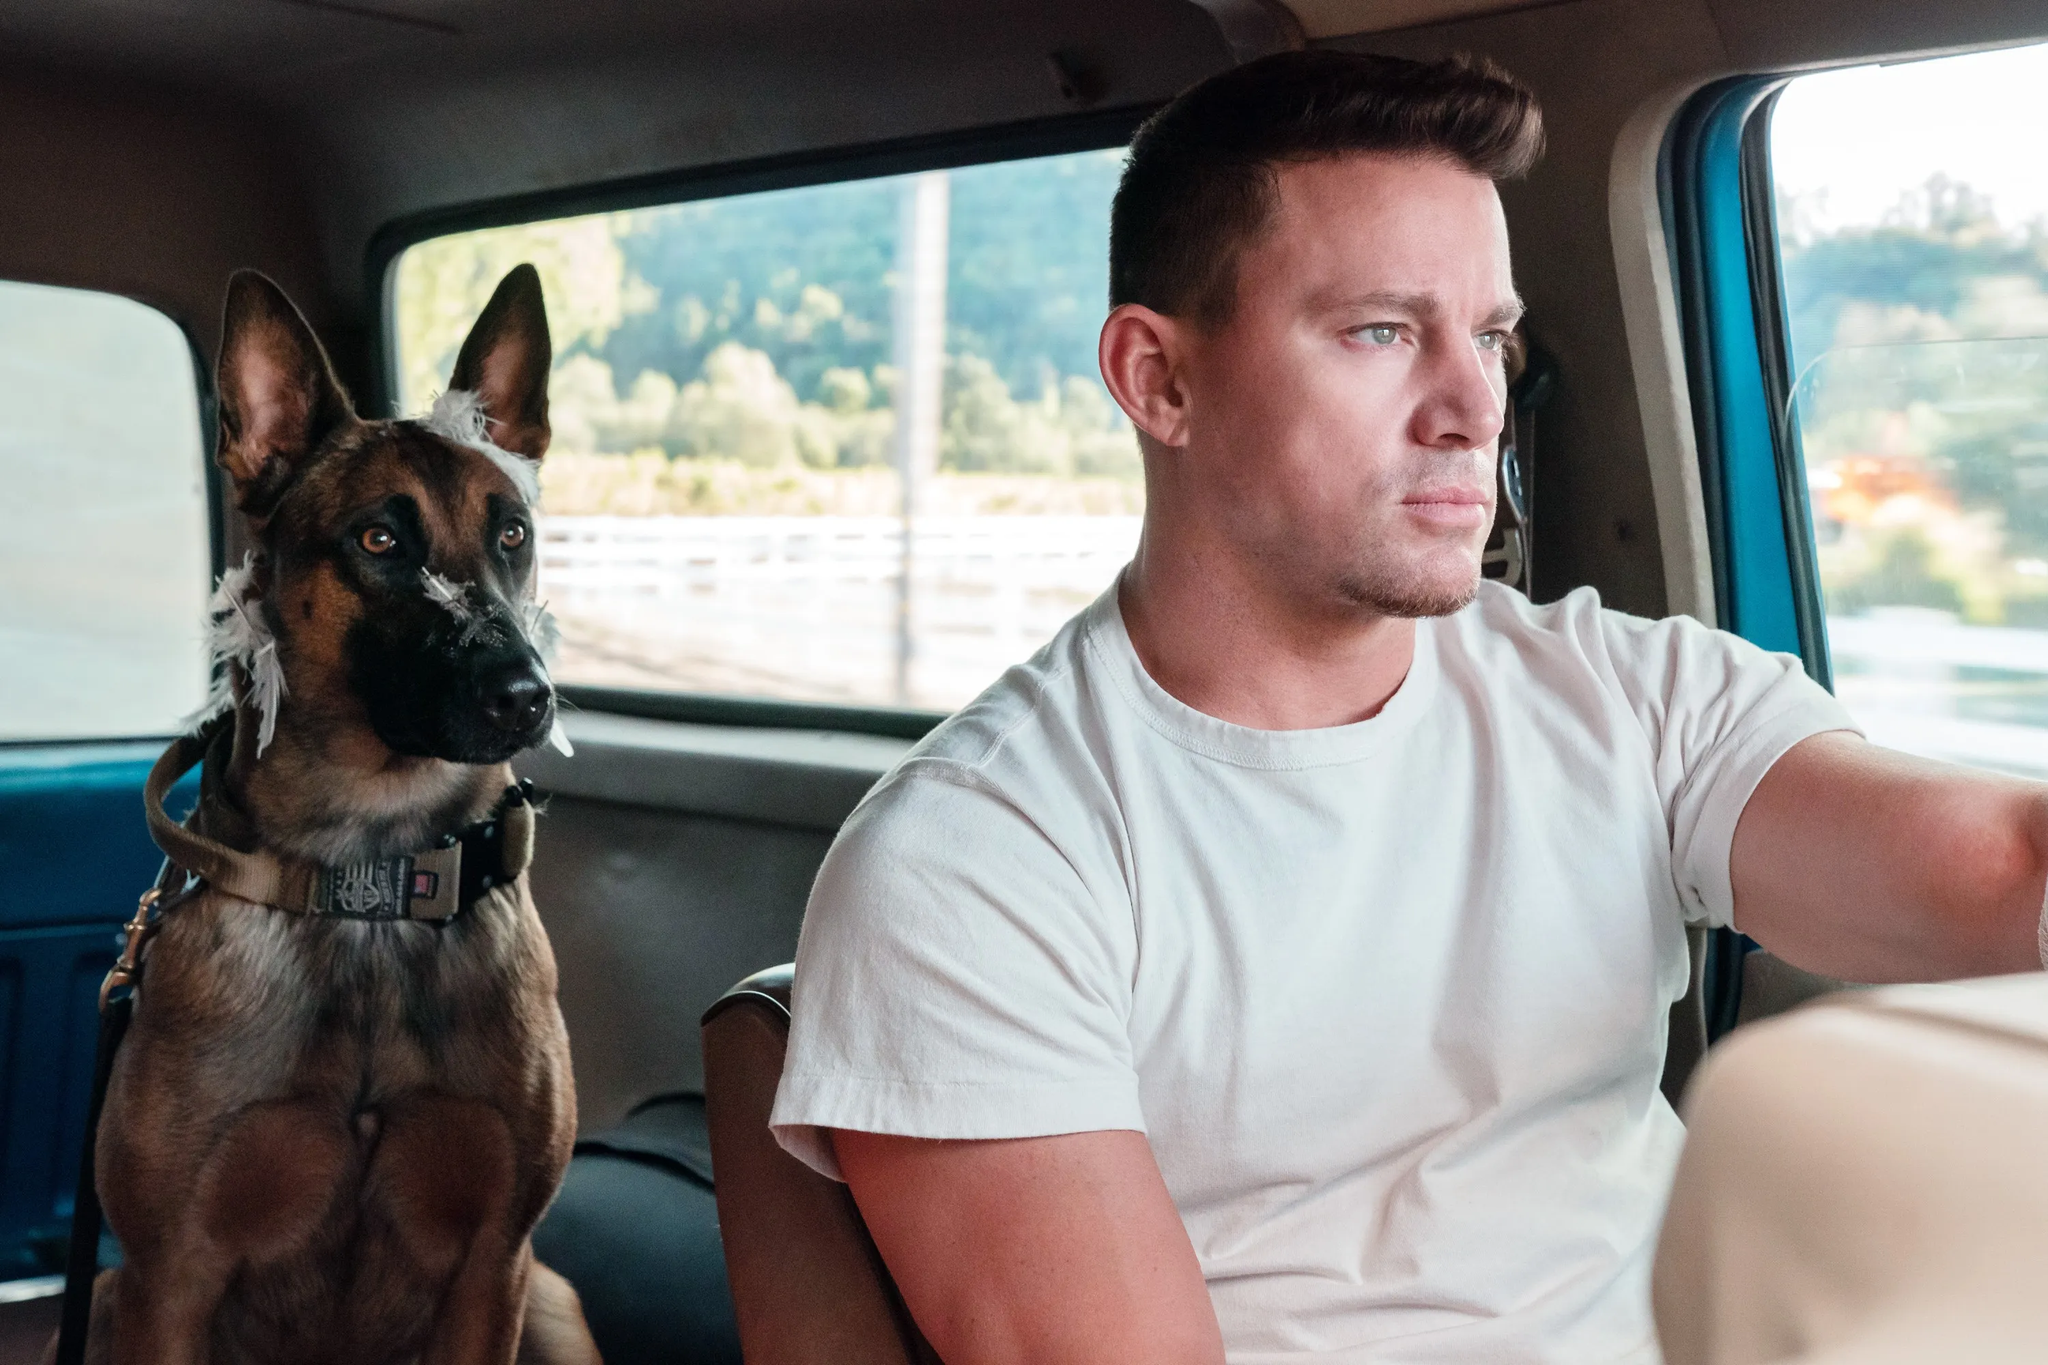Can you describe the main features of this image for me? The image features a man and a dog inside a vehicle. The man, who appears focused and composed, is driving and wearing a casual white t-shirt. On the other hand, the dog, with its brown fur and a striking blue collar, seems alert and is gazing directly at the camera. The sunlit scene accentuated by the blurred background, presumably trees and a road, infers that they are in motion. The essence of the image captures a serene journey shared between the man and his canine companion, presenting a candid moment of their travel together. 